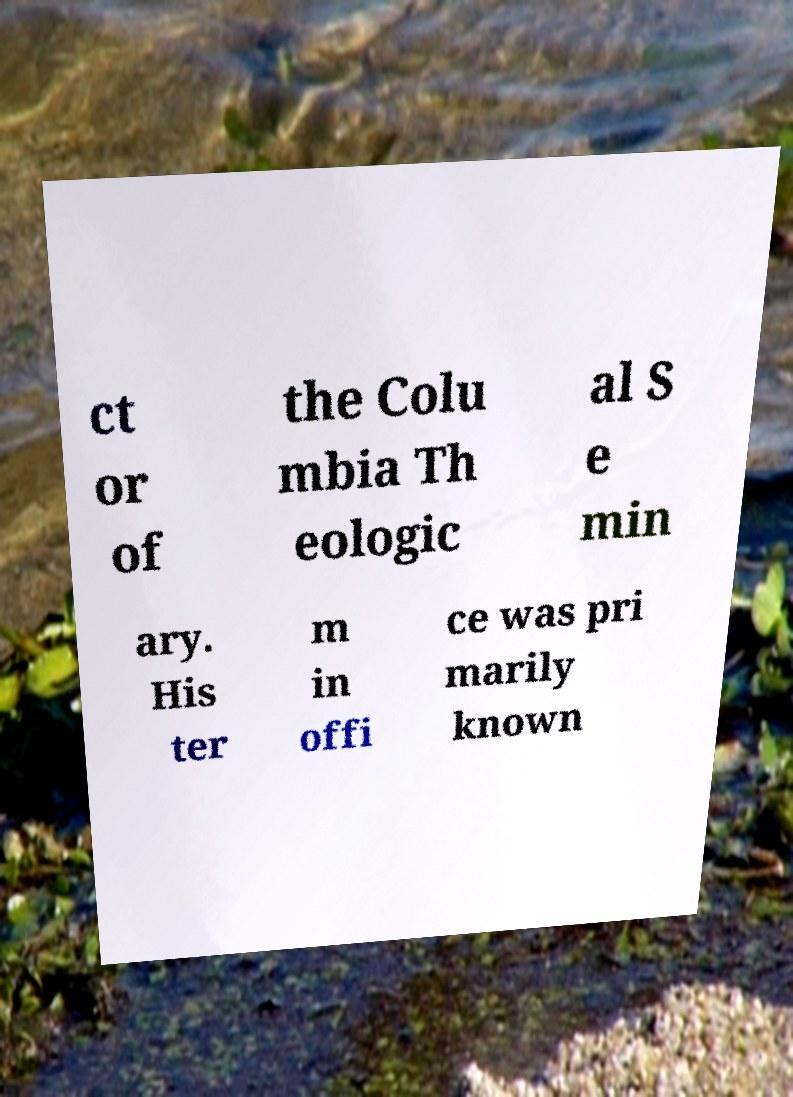Can you read and provide the text displayed in the image?This photo seems to have some interesting text. Can you extract and type it out for me? ct or of the Colu mbia Th eologic al S e min ary. His ter m in offi ce was pri marily known 